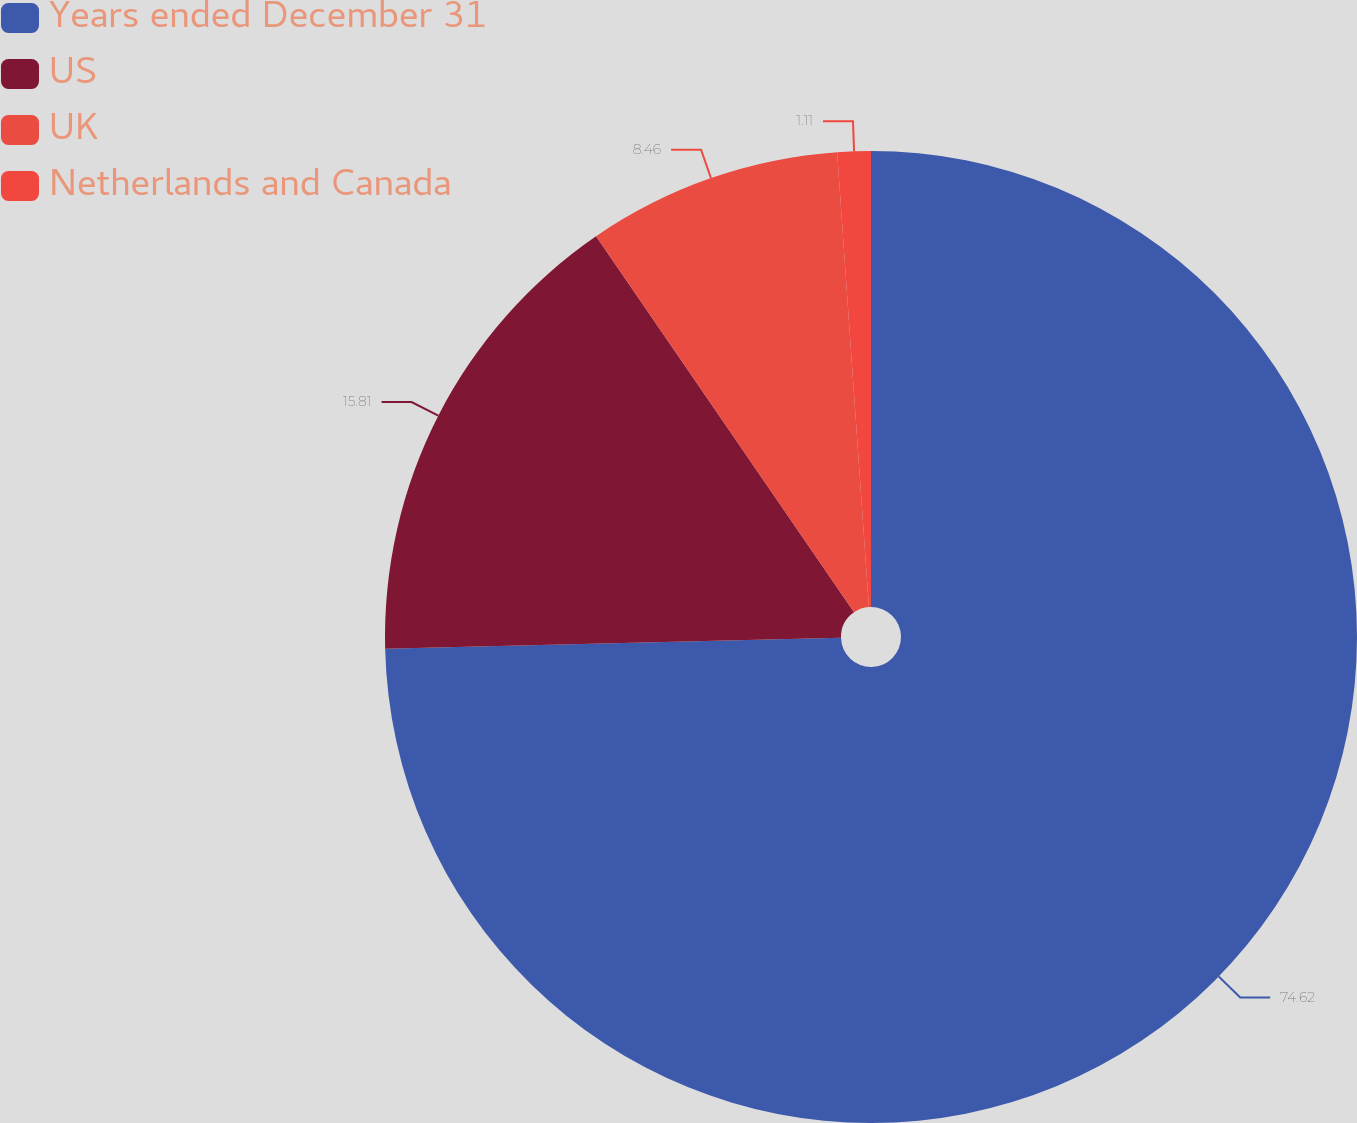Convert chart. <chart><loc_0><loc_0><loc_500><loc_500><pie_chart><fcel>Years ended December 31<fcel>US<fcel>UK<fcel>Netherlands and Canada<nl><fcel>74.61%<fcel>15.81%<fcel>8.46%<fcel>1.11%<nl></chart> 